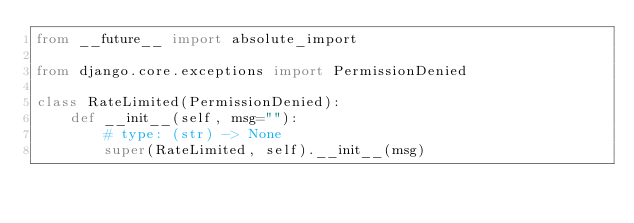Convert code to text. <code><loc_0><loc_0><loc_500><loc_500><_Python_>from __future__ import absolute_import

from django.core.exceptions import PermissionDenied

class RateLimited(PermissionDenied):
    def __init__(self, msg=""):
        # type: (str) -> None
        super(RateLimited, self).__init__(msg)
</code> 